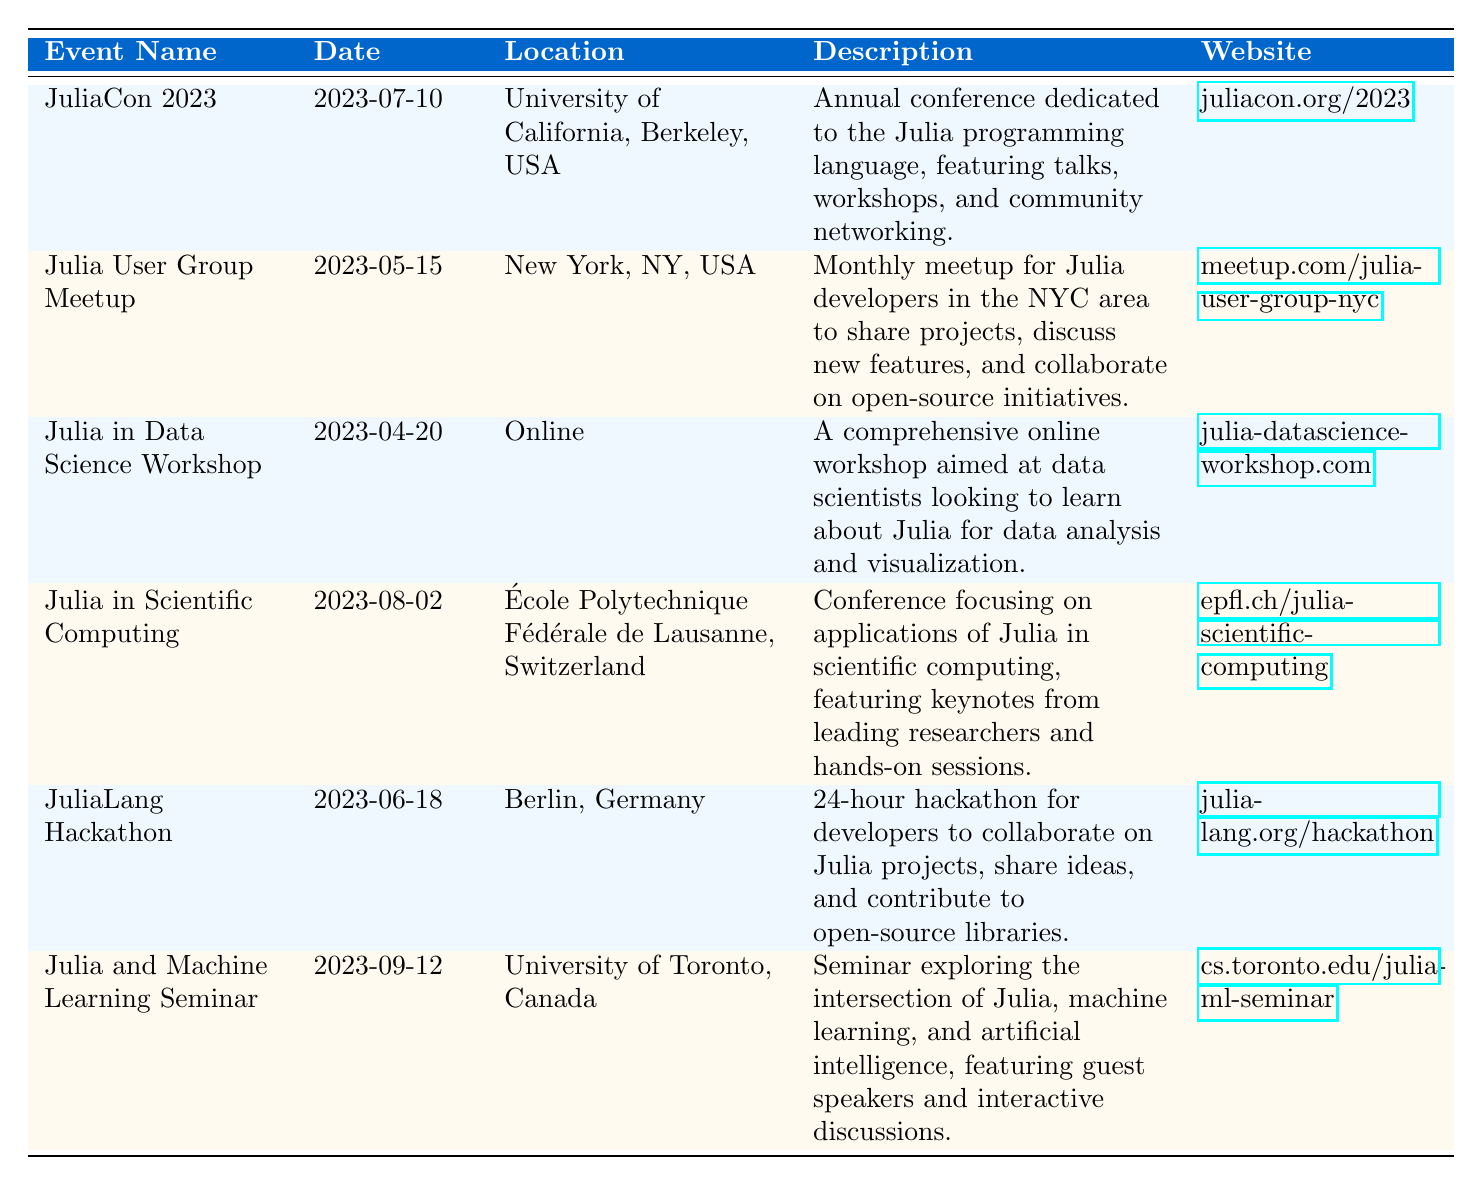What is the date of JuliaCon 2023? The table lists the event name "JuliaCon 2023" in the first row, corresponding to the event date provided in the same row, which is "2023-07-10".
Answer: 2023-07-10 Where is the Julia User Group Meetup located? The location for the "Julia User Group Meetup" is specified in the second row of the table, which states "New York, NY, USA".
Answer: New York, NY, USA Is there a workshop focused on data science in 2023? By inspecting the table, the event "Julia in Data Science Workshop" appears in the data, which confirms that there is a workshop dedicated to data science.
Answer: Yes Which event occurs latest in the year? Reviewing the "event_date" column, the latest date is "2023-09-12", which corresponds to "Julia and Machine Learning Seminar".
Answer: Julia and Machine Learning Seminar How many events take place in July 2023? The events are noted by their dates, and one event, "JuliaCon 2023", occurs in July (specifically on July 10). Therefore, there is only one event in that month.
Answer: 1 Which event is dedicated to scientific computing? The table explicitly mentions the event "Julia in Scientific Computing," found in the fourth row, indicating its focus on applications of Julia in that field.
Answer: Julia in Scientific Computing What is the name of the hackathon held in Berlin? The calendar reveals this event as "JuliaLang Hackathon", which is listed in the fifth row along with its specifics regarding location and description.
Answer: JuliaLang Hackathon How many events are scheduled in June 2023? Upon examining the rows, there are two events in June: "JuliaLang Hackathon" (June 18) and also earlier in May, meaning no June event specifically apart from that hackathon.
Answer: 1 Which event has a website related to machine learning? The event "Julia and Machine Learning Seminar" mentions machine learning in its description, and its associated link confirms this connection.
Answer: Julia and Machine Learning Seminar 